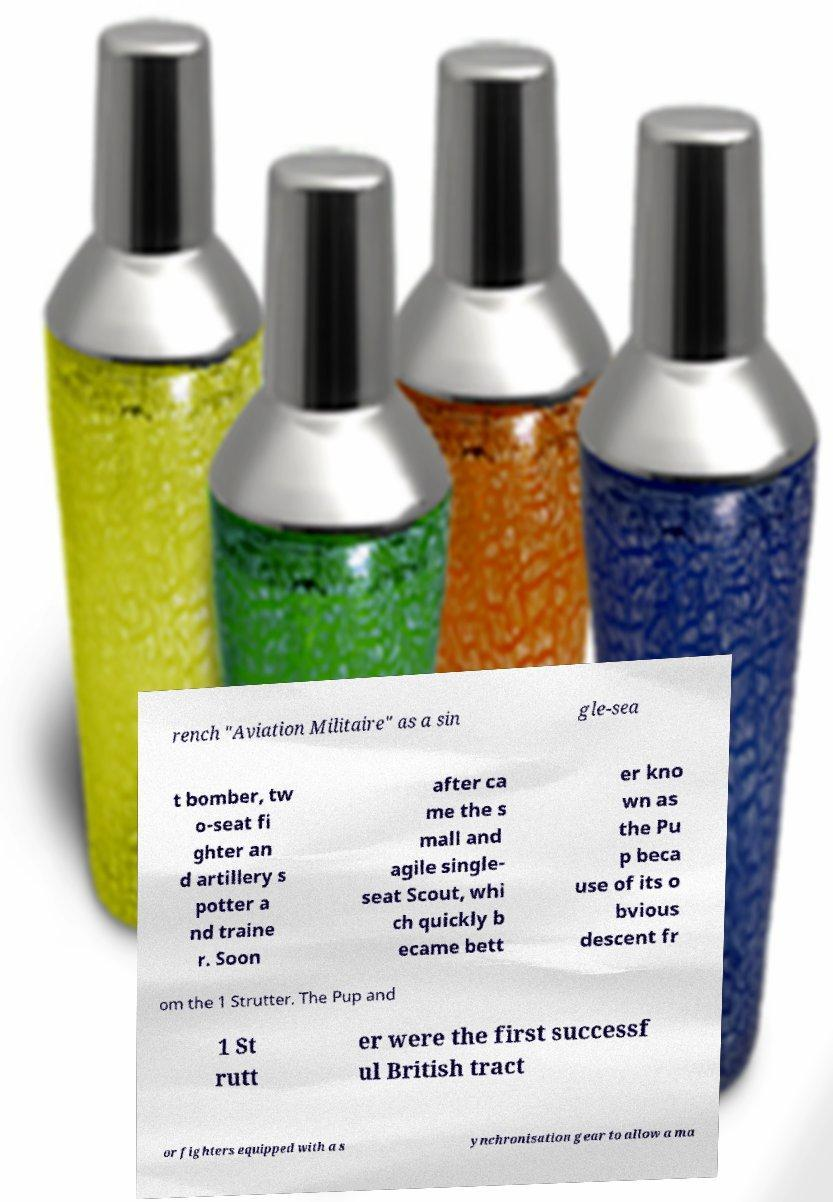I need the written content from this picture converted into text. Can you do that? rench "Aviation Militaire" as a sin gle-sea t bomber, tw o-seat fi ghter an d artillery s potter a nd traine r. Soon after ca me the s mall and agile single- seat Scout, whi ch quickly b ecame bett er kno wn as the Pu p beca use of its o bvious descent fr om the 1 Strutter. The Pup and 1 St rutt er were the first successf ul British tract or fighters equipped with a s ynchronisation gear to allow a ma 